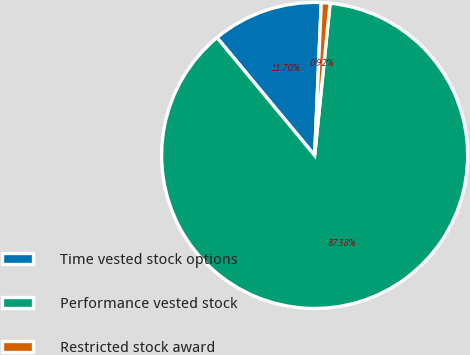Convert chart to OTSL. <chart><loc_0><loc_0><loc_500><loc_500><pie_chart><fcel>Time vested stock options<fcel>Performance vested stock<fcel>Restricted stock award<nl><fcel>11.7%<fcel>87.38%<fcel>0.92%<nl></chart> 